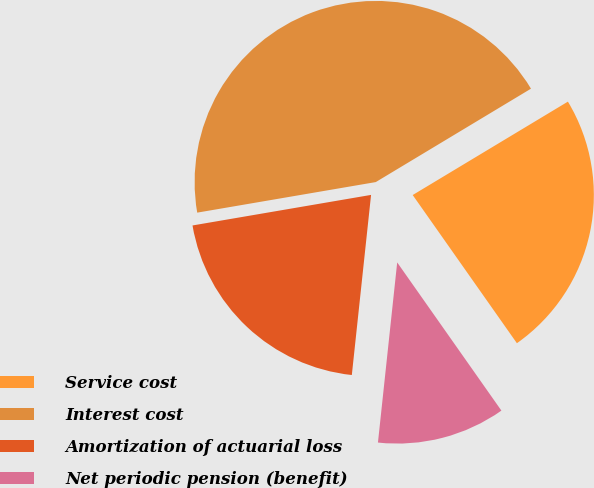Convert chart to OTSL. <chart><loc_0><loc_0><loc_500><loc_500><pie_chart><fcel>Service cost<fcel>Interest cost<fcel>Amortization of actuarial loss<fcel>Net periodic pension (benefit)<nl><fcel>23.87%<fcel>44.08%<fcel>20.61%<fcel>11.45%<nl></chart> 